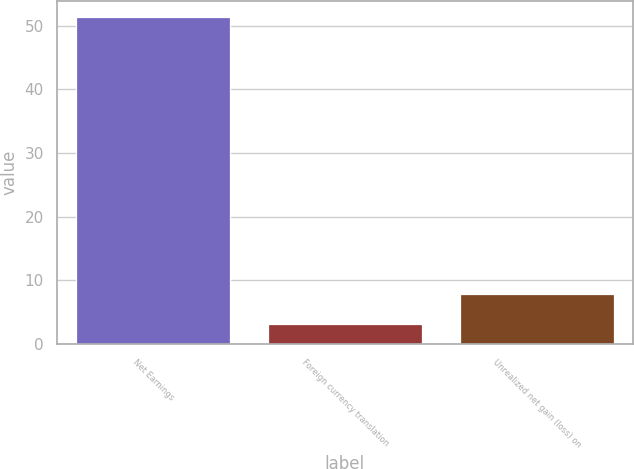Convert chart. <chart><loc_0><loc_0><loc_500><loc_500><bar_chart><fcel>Net Earnings<fcel>Foreign currency translation<fcel>Unrealized net gain (loss) on<nl><fcel>51.3<fcel>3.1<fcel>7.92<nl></chart> 